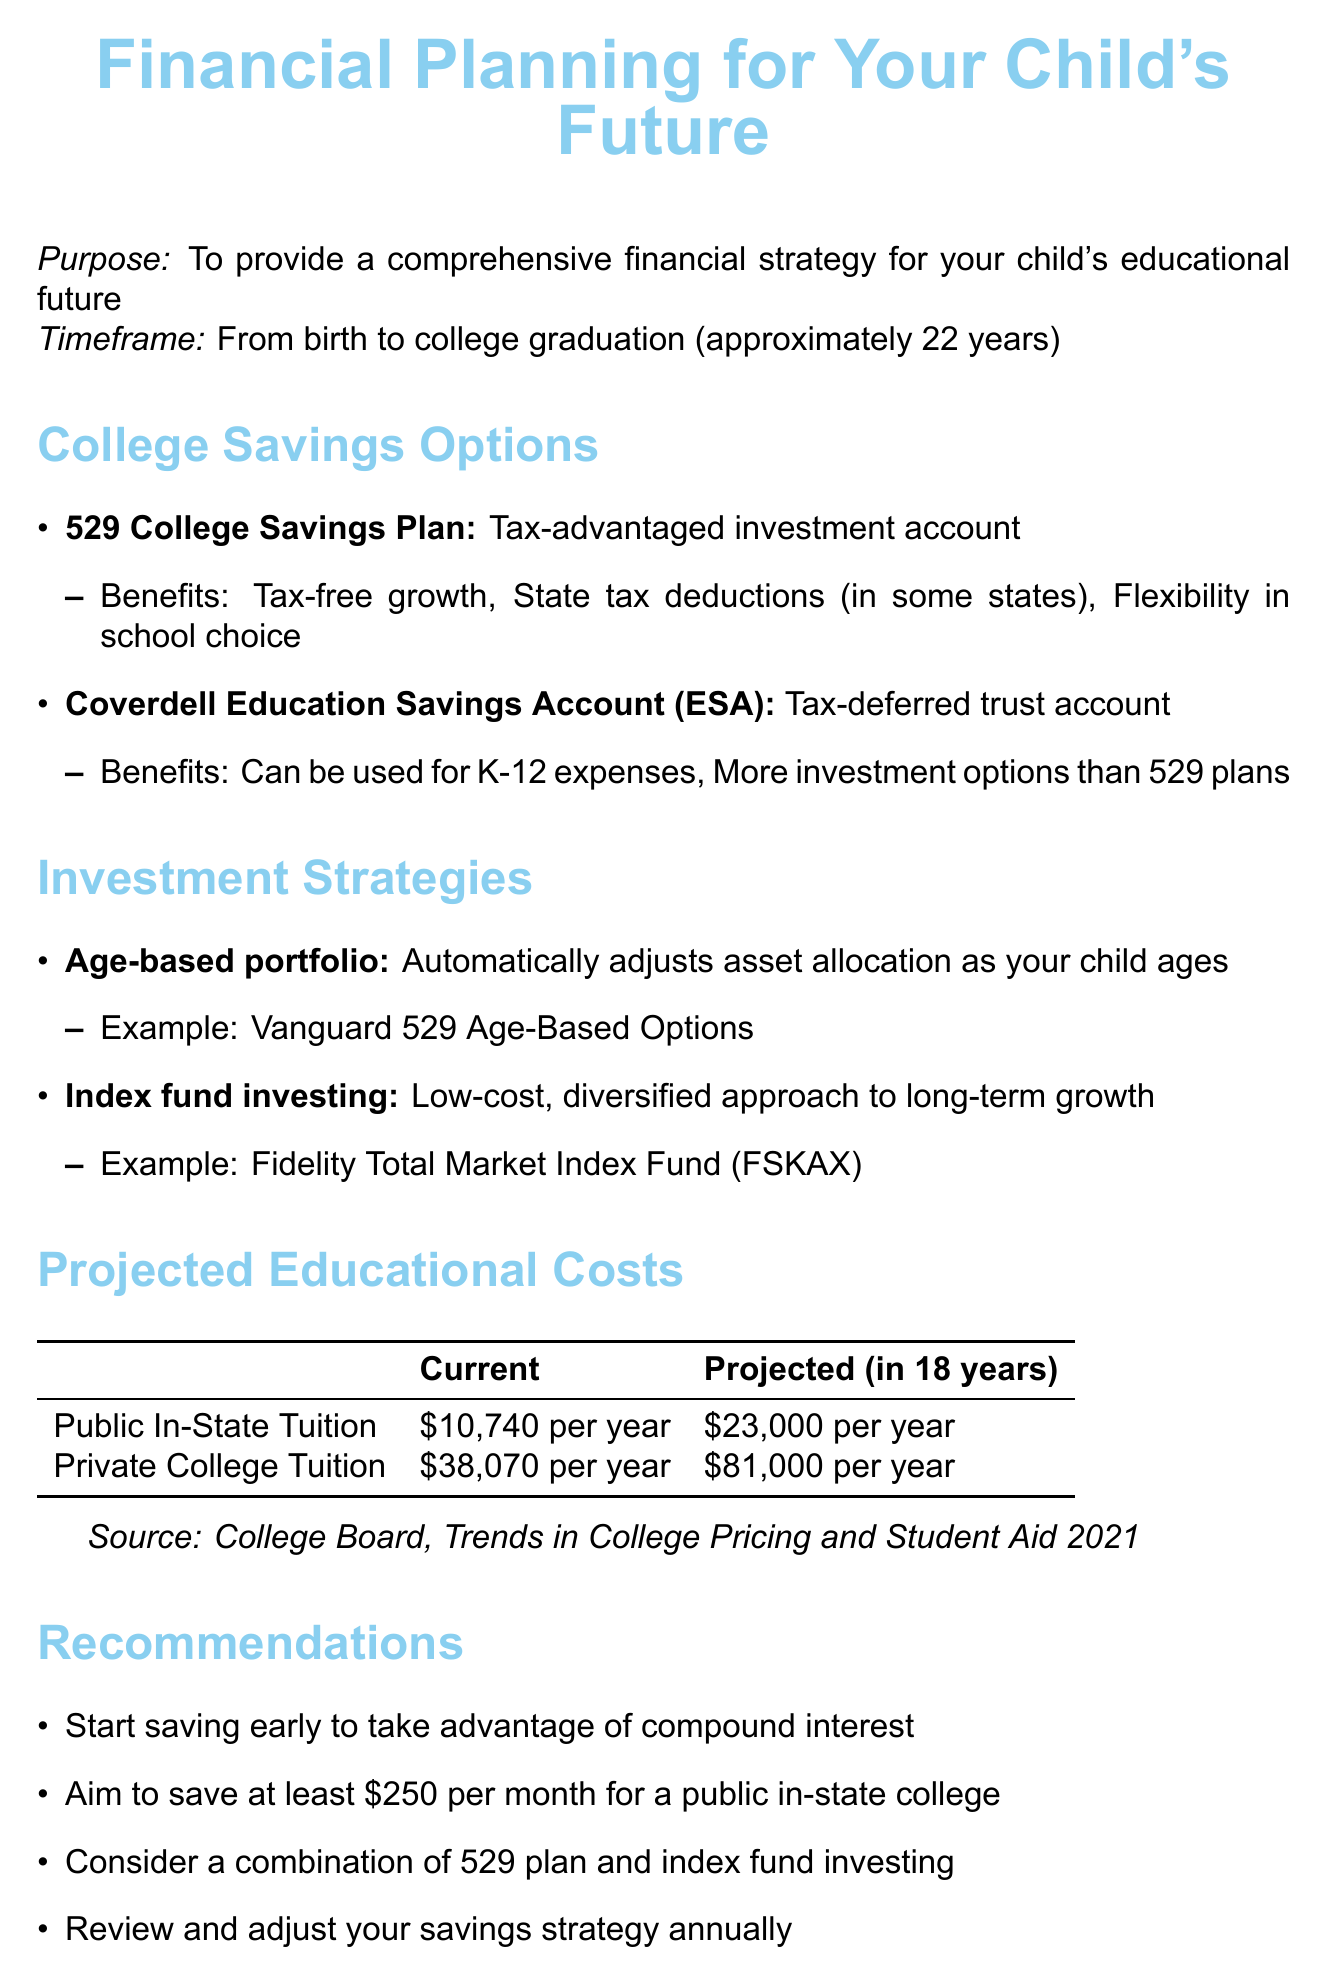What is the purpose of the report? The purpose is to provide a comprehensive financial strategy for your child's educational future.
Answer: To provide a comprehensive financial strategy for your child's educational future How much is the current public in-state tuition? The document states the current public in-state tuition is mentioned directly.
Answer: $10,740 per year What is the projected private college tuition in 18 years? The projected private college tuition for the year in 18 years is specified in the document.
Answer: $81,000 per year What is one benefit of the 529 College Savings Plan? The document lists several benefits of the 529 College Savings Plan; asking for one will refer to just one of them.
Answer: Tax-free growth Which investment strategy adjusts automatically as the child ages? The investment strategy that adjusts asset allocation as the child ages is mentioned in the document.
Answer: Age-based portfolio How much should one aim to save monthly for a public in-state college? The document provides a specific amount to aim to save per month.
Answer: $250 What is a major consideration when planning for college savings? The document includes several considerations, and one significant mention is highlighted in the additional considerations section.
Answer: Factor in potential financial aid and scholarships What type of account is a Coverdell Education Savings Account? The account type for the Coverdell Education Savings Account is explicitly described in the document.
Answer: Tax-deferred trust account What is another term for 529 plans in the document? The report gives a formal name for these plans, often referred to by another term.
Answer: 529 College Savings Plan 